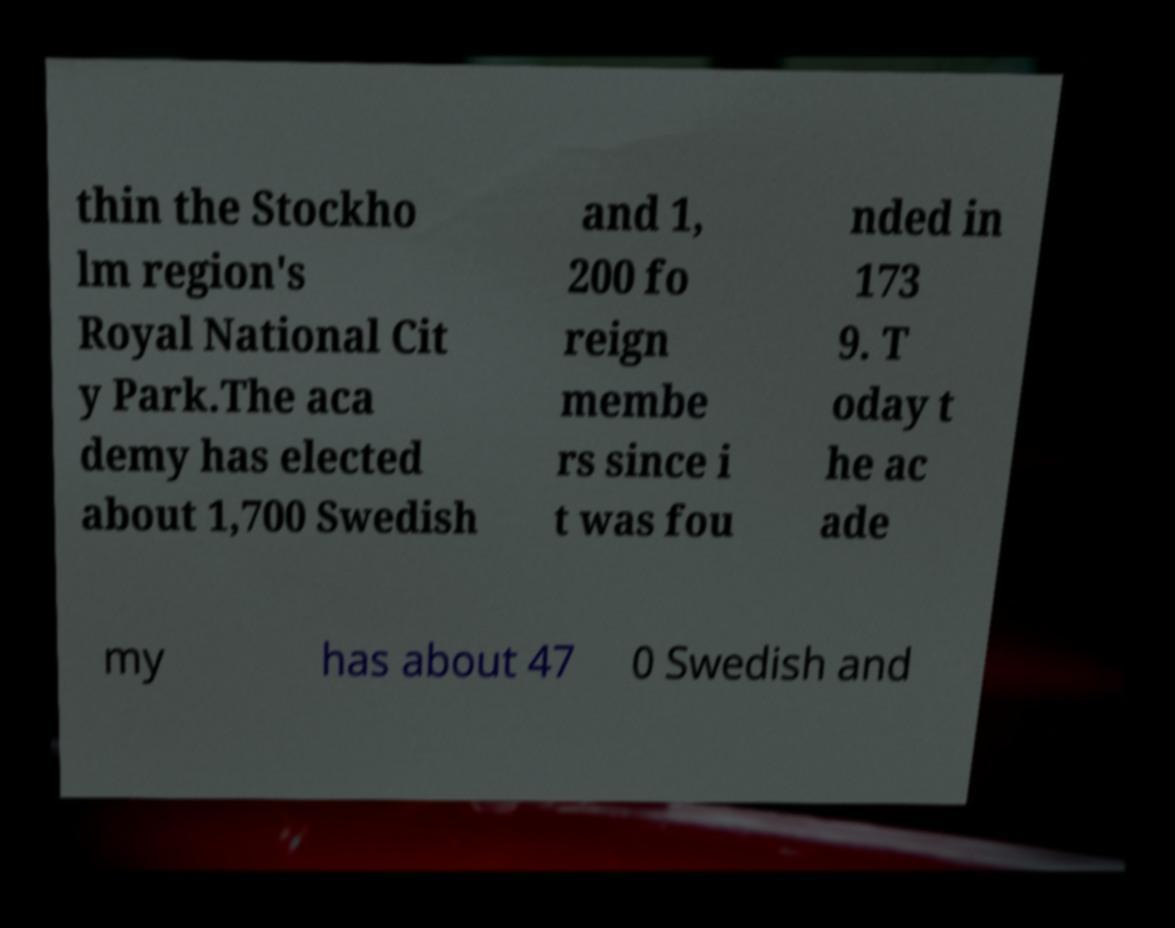What messages or text are displayed in this image? I need them in a readable, typed format. thin the Stockho lm region's Royal National Cit y Park.The aca demy has elected about 1,700 Swedish and 1, 200 fo reign membe rs since i t was fou nded in 173 9. T oday t he ac ade my has about 47 0 Swedish and 